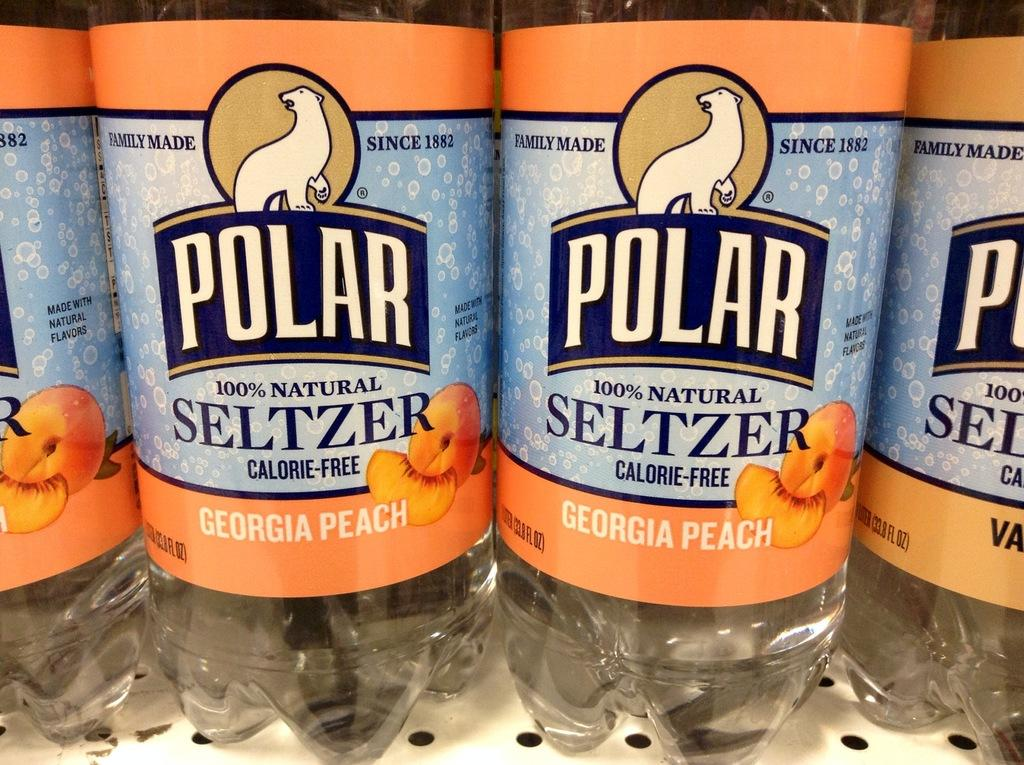What objects can be seen in the image? There are bottles present in the image. How are the bottles arranged in the image? The bottles are in a rack. How many quince are on the rack with the bottles? There are no quince present in the image; only bottles can be seen in the rack. 